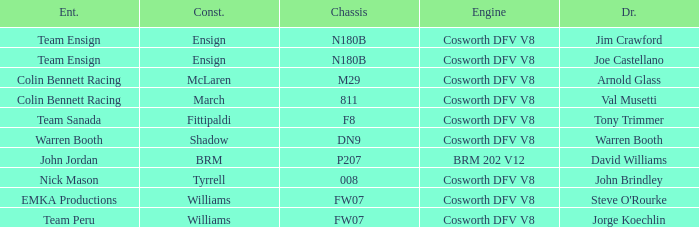Can you parse all the data within this table? {'header': ['Ent.', 'Const.', 'Chassis', 'Engine', 'Dr.'], 'rows': [['Team Ensign', 'Ensign', 'N180B', 'Cosworth DFV V8', 'Jim Crawford'], ['Team Ensign', 'Ensign', 'N180B', 'Cosworth DFV V8', 'Joe Castellano'], ['Colin Bennett Racing', 'McLaren', 'M29', 'Cosworth DFV V8', 'Arnold Glass'], ['Colin Bennett Racing', 'March', '811', 'Cosworth DFV V8', 'Val Musetti'], ['Team Sanada', 'Fittipaldi', 'F8', 'Cosworth DFV V8', 'Tony Trimmer'], ['Warren Booth', 'Shadow', 'DN9', 'Cosworth DFV V8', 'Warren Booth'], ['John Jordan', 'BRM', 'P207', 'BRM 202 V12', 'David Williams'], ['Nick Mason', 'Tyrrell', '008', 'Cosworth DFV V8', 'John Brindley'], ['EMKA Productions', 'Williams', 'FW07', 'Cosworth DFV V8', "Steve O'Rourke"], ['Team Peru', 'Williams', 'FW07', 'Cosworth DFV V8', 'Jorge Koechlin']]} Who built Warren Booth's car with the Cosworth DFV V8 engine? Shadow. 